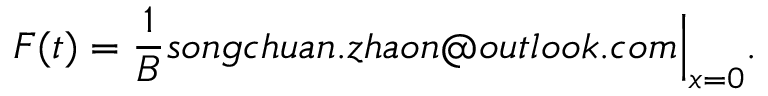<formula> <loc_0><loc_0><loc_500><loc_500>F ( t ) = \frac { 1 } { B } s o n g c h u a n . z h a o n o u t l o o k . c o m \Big | _ { x = 0 } .</formula> 